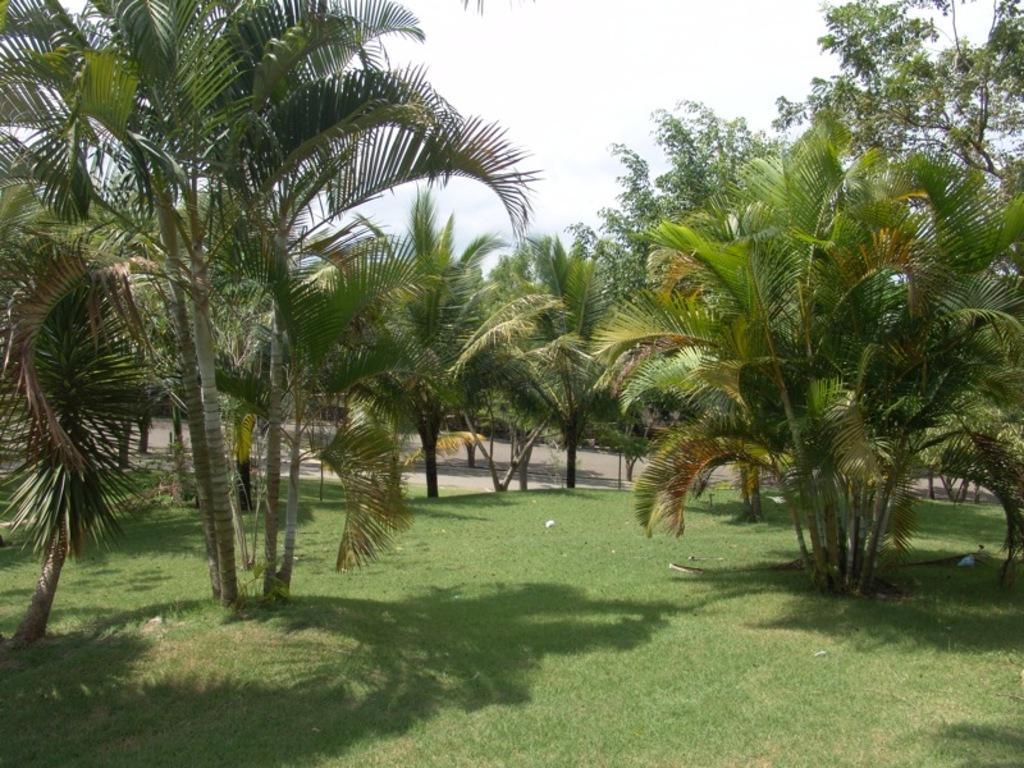In one or two sentences, can you explain what this image depicts? In this image I can see some grass on the ground and few trees. In the background I can see the road and the sky. 